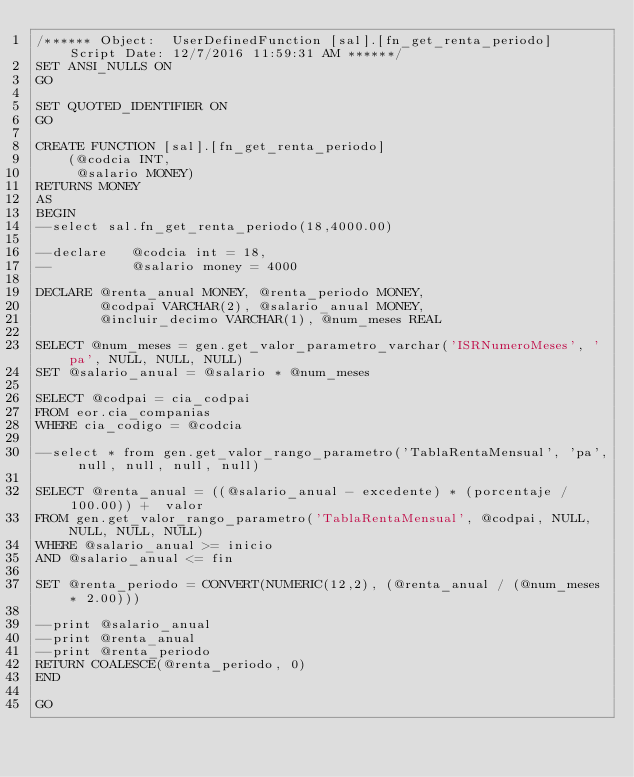Convert code to text. <code><loc_0><loc_0><loc_500><loc_500><_SQL_>/****** Object:  UserDefinedFunction [sal].[fn_get_renta_periodo]    Script Date: 12/7/2016 11:59:31 AM ******/
SET ANSI_NULLS ON
GO

SET QUOTED_IDENTIFIER ON
GO

CREATE FUNCTION [sal].[fn_get_renta_periodo]
	(@codcia INT, 
     @salario MONEY)
RETURNS MONEY
AS
BEGIN
--select sal.fn_get_renta_periodo(18,4000.00)

--declare 	@codcia int = 18, 
--			@salario money = 4000

DECLARE @renta_anual MONEY, @renta_periodo MONEY,
		@codpai VARCHAR(2), @salario_anual MONEY,
		@incluir_decimo VARCHAR(1), @num_meses REAL

SELECT @num_meses = gen.get_valor_parametro_varchar('ISRNumeroMeses', 'pa', NULL, NULL, NULL)
SET @salario_anual = @salario * @num_meses

SELECT @codpai = cia_codpai
FROM eor.cia_companias
WHERE cia_codigo = @codcia

--select * from gen.get_valor_rango_parametro('TablaRentaMensual', 'pa', null, null, null, null)

SELECT @renta_anual = ((@salario_anual - excedente) * (porcentaje / 100.00)) +  valor
FROM gen.get_valor_rango_parametro('TablaRentaMensual', @codpai, NULL, NULL, NULL, NULL)
WHERE @salario_anual >= inicio
AND @salario_anual <= fin

SET @renta_periodo = CONVERT(NUMERIC(12,2), (@renta_anual / (@num_meses * 2.00)))

--print @salario_anual
--print @renta_anual
--print @renta_periodo
RETURN COALESCE(@renta_periodo, 0)
END

GO


</code> 